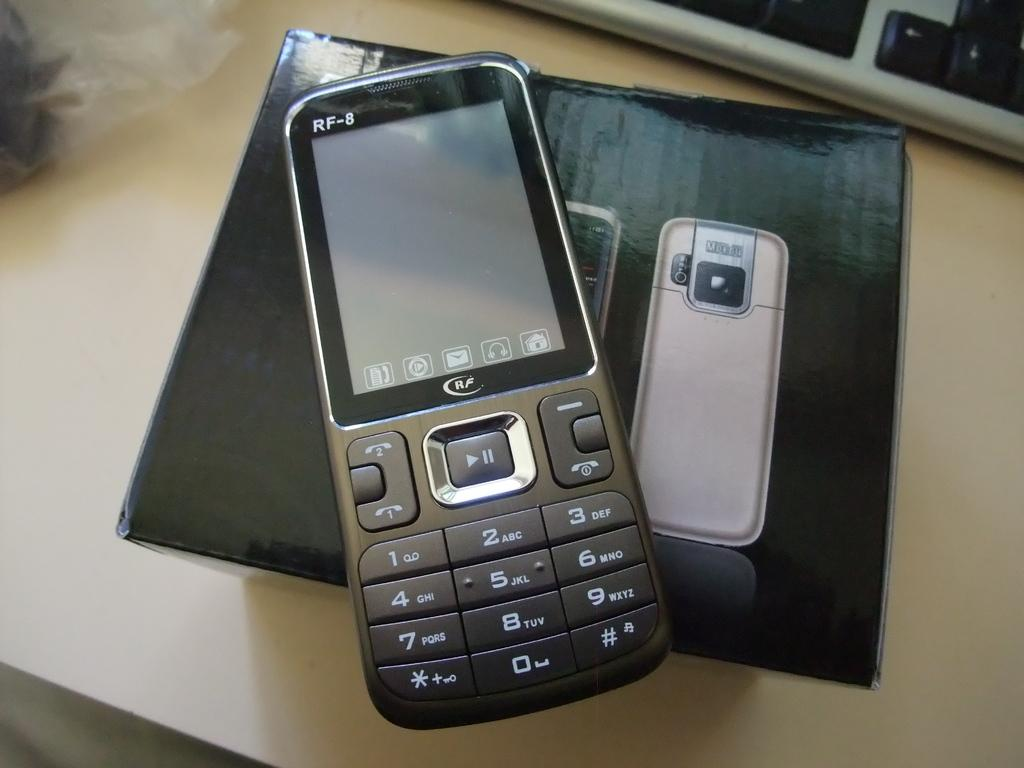Provide a one-sentence caption for the provided image. RF 8 black cellphone that shows the home screen. 